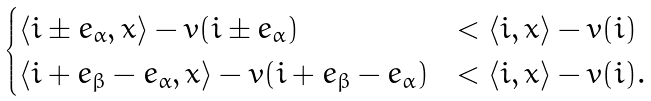<formula> <loc_0><loc_0><loc_500><loc_500>\begin{cases} \langle i \pm e _ { \alpha } , x \rangle - v ( i \pm e _ { \alpha } ) & < \langle i , x \rangle - v ( i ) \\ \langle i + e _ { \beta } - e _ { \alpha } , x \rangle - v ( i + e _ { \beta } - e _ { \alpha } ) & < \langle i , x \rangle - v ( i ) . \end{cases}</formula> 